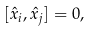Convert formula to latex. <formula><loc_0><loc_0><loc_500><loc_500>[ { \hat { x } } _ { i } , { \hat { x } } _ { j } ] = 0 ,</formula> 